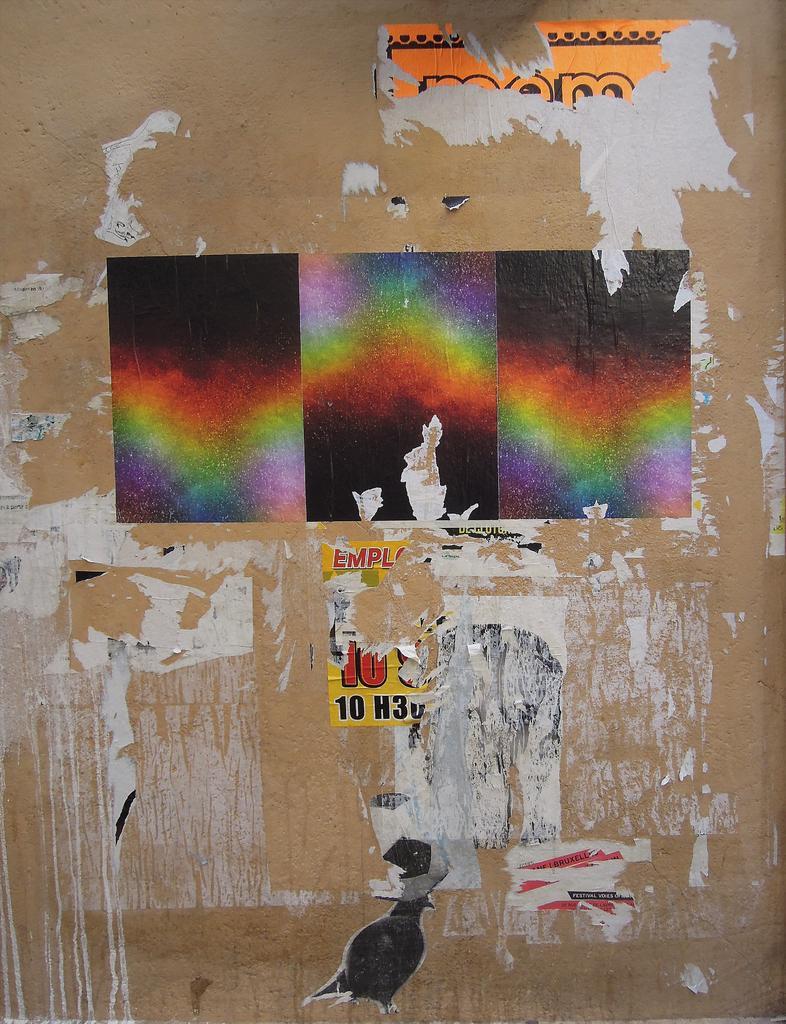Please provide a concise description of this image. In this picture I can see few posts on the wall. 